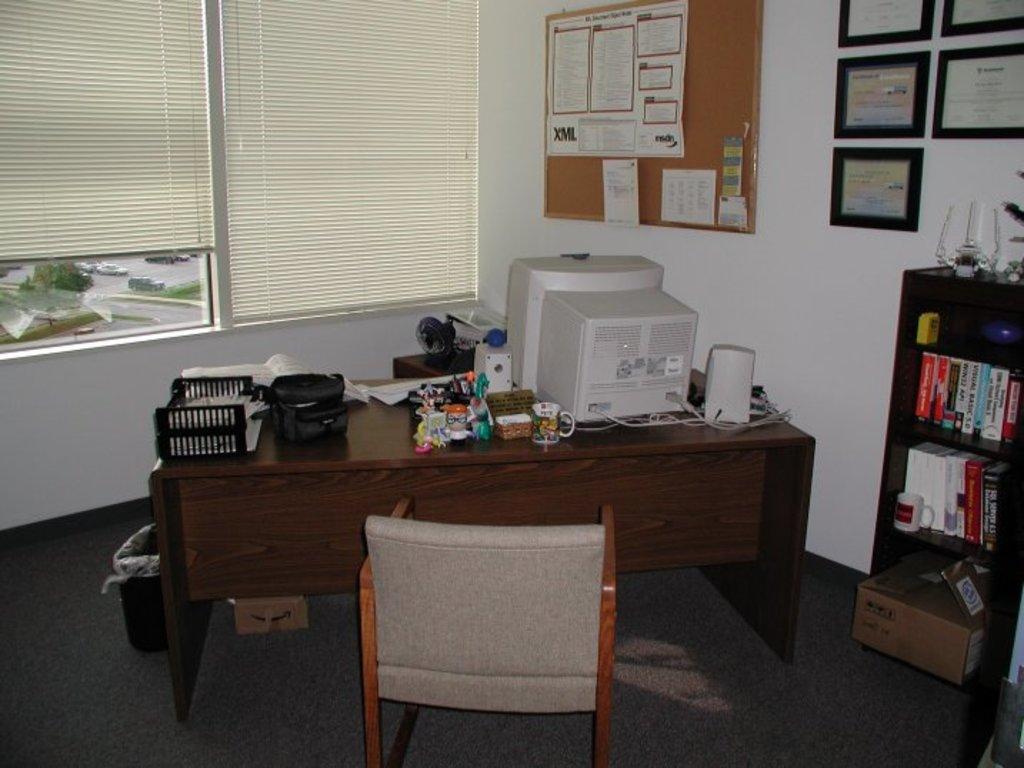Please provide a concise description of this image. In the image, in a room there is a table and on the table there is a computer system and many other objects, there is a chair in front of the table and on the right side there are many books kept in the shelves, above that there are some frames attached to the wall and on the left side there is a notice board and many papers were stick to that notice board and in the background there are two windows and there are blinds to those windows. 